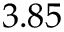Convert formula to latex. <formula><loc_0><loc_0><loc_500><loc_500>3 . 8 5</formula> 